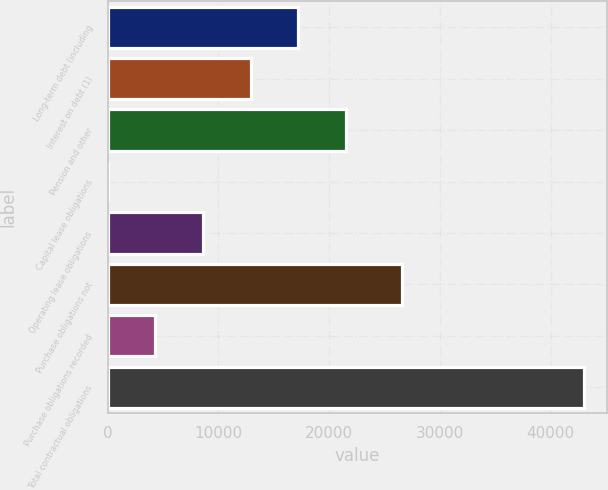<chart> <loc_0><loc_0><loc_500><loc_500><bar_chart><fcel>Long-term debt (including<fcel>Interest on debt (1)<fcel>Pension and other<fcel>Capital lease obligations<fcel>Operating lease obligations<fcel>Purchase obligations not<fcel>Purchase obligations recorded<fcel>Total contractual obligations<nl><fcel>17196.4<fcel>12900.3<fcel>21492.5<fcel>12<fcel>8604.2<fcel>26608<fcel>4308.1<fcel>42973<nl></chart> 